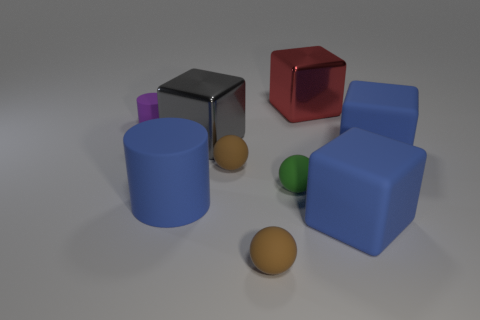Subtract all brown rubber balls. How many balls are left? 1 Add 1 gray rubber blocks. How many objects exist? 10 Subtract all cyan cubes. Subtract all gray balls. How many cubes are left? 4 Subtract all spheres. How many objects are left? 6 Subtract all brown balls. Subtract all big matte things. How many objects are left? 4 Add 6 tiny purple rubber cylinders. How many tiny purple rubber cylinders are left? 7 Add 2 tiny matte balls. How many tiny matte balls exist? 5 Subtract 0 yellow cubes. How many objects are left? 9 